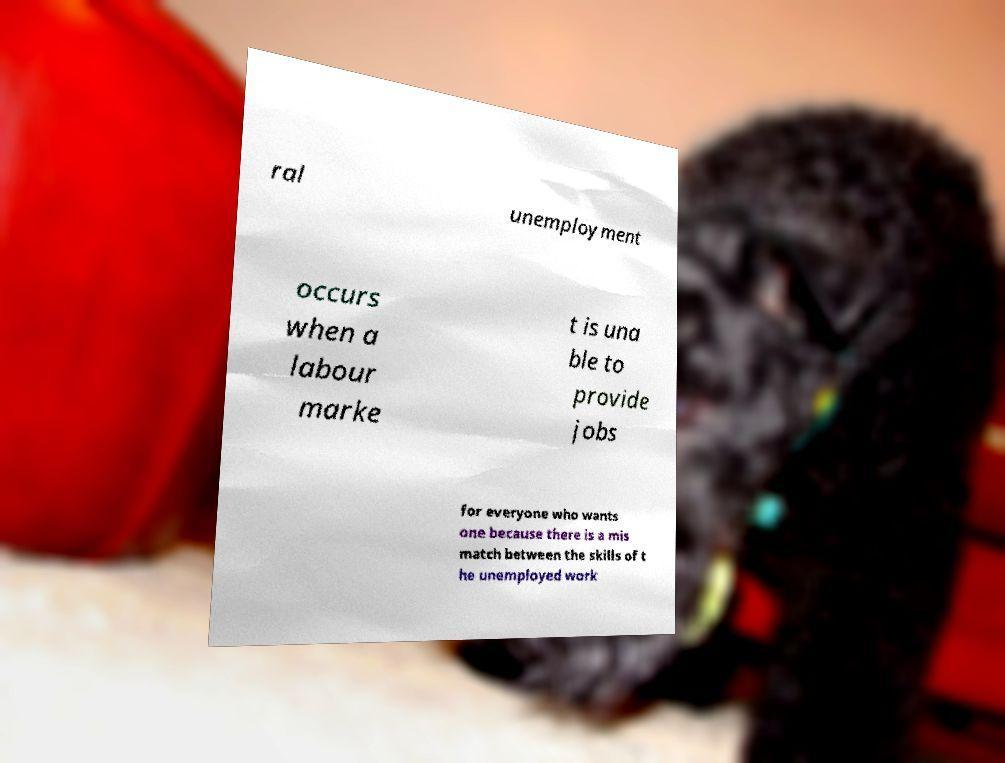What messages or text are displayed in this image? I need them in a readable, typed format. ral unemployment occurs when a labour marke t is una ble to provide jobs for everyone who wants one because there is a mis match between the skills of t he unemployed work 